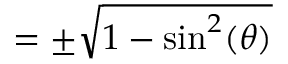Convert formula to latex. <formula><loc_0><loc_0><loc_500><loc_500>= \pm { \sqrt { 1 - \sin ^ { 2 } ( \theta ) } }</formula> 